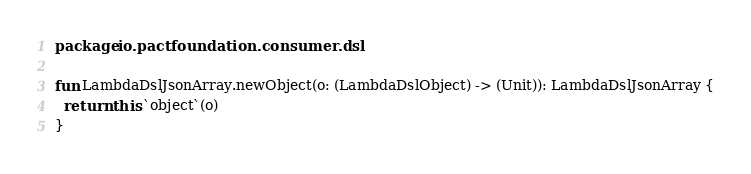Convert code to text. <code><loc_0><loc_0><loc_500><loc_500><_Kotlin_>package io.pactfoundation.consumer.dsl

fun LambdaDslJsonArray.newObject(o: (LambdaDslObject) -> (Unit)): LambdaDslJsonArray {
  return this.`object`(o)
}
</code> 